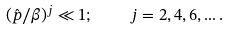Convert formula to latex. <formula><loc_0><loc_0><loc_500><loc_500>( \hat { p } / \beta ) ^ { j } \ll 1 ; \quad j = 2 , 4 , 6 , \dots .</formula> 